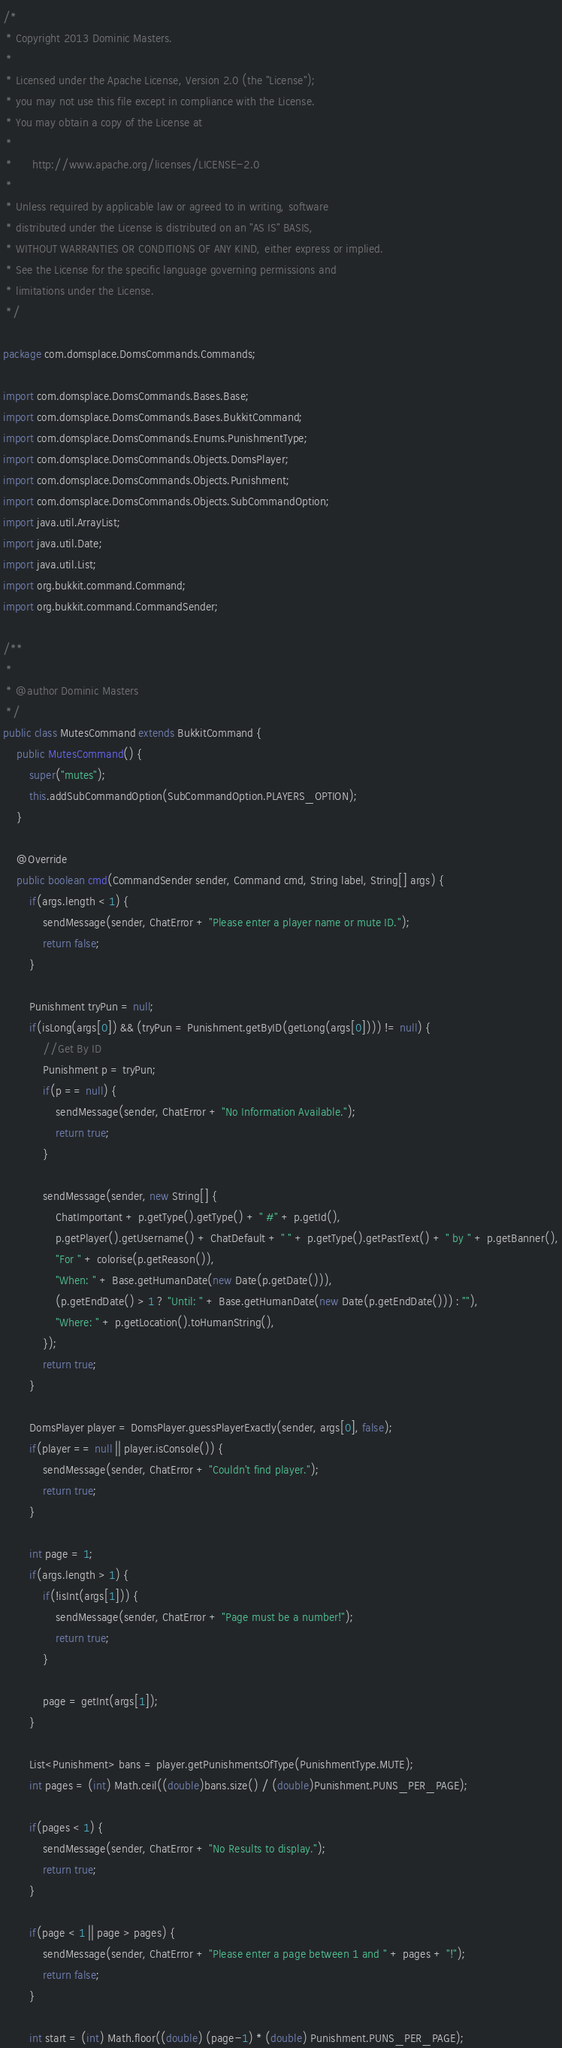<code> <loc_0><loc_0><loc_500><loc_500><_Java_>/*
 * Copyright 2013 Dominic Masters.
 *
 * Licensed under the Apache License, Version 2.0 (the "License");
 * you may not use this file except in compliance with the License.
 * You may obtain a copy of the License at
 *
 *      http://www.apache.org/licenses/LICENSE-2.0
 *
 * Unless required by applicable law or agreed to in writing, software
 * distributed under the License is distributed on an "AS IS" BASIS,
 * WITHOUT WARRANTIES OR CONDITIONS OF ANY KIND, either express or implied.
 * See the License for the specific language governing permissions and
 * limitations under the License.
 */

package com.domsplace.DomsCommands.Commands;

import com.domsplace.DomsCommands.Bases.Base;
import com.domsplace.DomsCommands.Bases.BukkitCommand;
import com.domsplace.DomsCommands.Enums.PunishmentType;
import com.domsplace.DomsCommands.Objects.DomsPlayer;
import com.domsplace.DomsCommands.Objects.Punishment;
import com.domsplace.DomsCommands.Objects.SubCommandOption;
import java.util.ArrayList;
import java.util.Date;
import java.util.List;
import org.bukkit.command.Command;
import org.bukkit.command.CommandSender;

/**
 *
 * @author Dominic Masters
 */
public class MutesCommand extends BukkitCommand {    
    public MutesCommand() {
        super("mutes");
        this.addSubCommandOption(SubCommandOption.PLAYERS_OPTION);
    }
    
    @Override
    public boolean cmd(CommandSender sender, Command cmd, String label, String[] args) {
        if(args.length < 1) {
            sendMessage(sender, ChatError + "Please enter a player name or mute ID.");
            return false;
        }
        
        Punishment tryPun = null;
        if(isLong(args[0]) && (tryPun = Punishment.getByID(getLong(args[0]))) != null) {
            //Get By ID
            Punishment p = tryPun;
            if(p == null) {
                sendMessage(sender, ChatError + "No Information Available.");
                return true;
            }
            
            sendMessage(sender, new String[] {
                ChatImportant + p.getType().getType() + " #" + p.getId(),
                p.getPlayer().getUsername() + ChatDefault + " " + p.getType().getPastText() + " by " + p.getBanner(),
                "For " + colorise(p.getReason()),
                "When: " + Base.getHumanDate(new Date(p.getDate())),
                (p.getEndDate() > 1 ? "Until: " + Base.getHumanDate(new Date(p.getEndDate())) : ""),
                "Where: " + p.getLocation().toHumanString(),
            });
            return true;
        }
        
        DomsPlayer player = DomsPlayer.guessPlayerExactly(sender, args[0], false);
        if(player == null || player.isConsole()) {
            sendMessage(sender, ChatError + "Couldn't find player.");
            return true;
        }
        
        int page = 1;
        if(args.length > 1) {
            if(!isInt(args[1])) {
                sendMessage(sender, ChatError + "Page must be a number!");
                return true;
            }
            
            page = getInt(args[1]);
        }
        
        List<Punishment> bans = player.getPunishmentsOfType(PunishmentType.MUTE);
        int pages = (int) Math.ceil((double)bans.size() / (double)Punishment.PUNS_PER_PAGE);
        
        if(pages < 1) {
            sendMessage(sender, ChatError + "No Results to display.");
            return true;
        }
        
        if(page < 1 || page > pages) {
            sendMessage(sender, ChatError + "Please enter a page between 1 and " + pages + "!");
            return false;
        }
        
        int start = (int) Math.floor((double) (page-1) * (double) Punishment.PUNS_PER_PAGE);</code> 